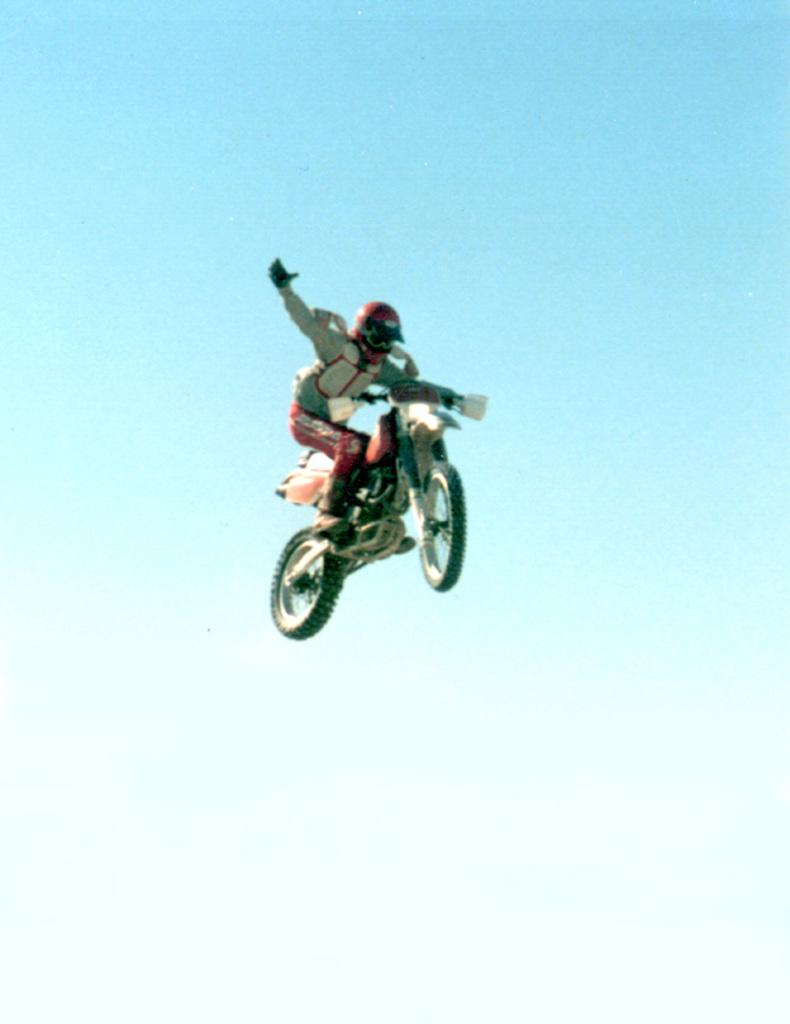Who is performing the stunt in the image? There is a man in the image performing a stunt. What type of stunt is the man performing? The stunt involves a bike. What is the bike doing during the stunt? The bike is in the air during the stunt. What key is the man using to unlock the bike during the stunt? There is no key present in the image, and the man is not unlocking a bike; he is performing a stunt with a bike that is already in the air. 